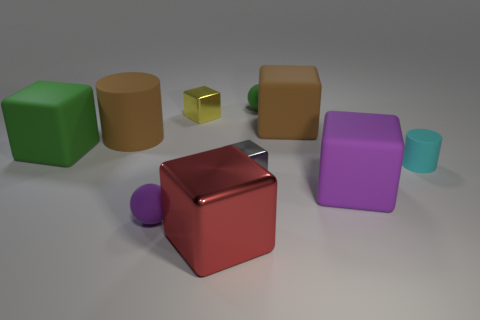Subtract 1 cubes. How many cubes are left? 5 Subtract all purple blocks. How many blocks are left? 5 Subtract all tiny gray metallic blocks. How many blocks are left? 5 Subtract all brown cubes. Subtract all purple balls. How many cubes are left? 5 Subtract all cylinders. How many objects are left? 8 Add 6 large green rubber things. How many large green rubber things are left? 7 Add 3 large red metallic spheres. How many large red metallic spheres exist? 3 Subtract 0 yellow balls. How many objects are left? 10 Subtract all gray blocks. Subtract all tiny metal objects. How many objects are left? 7 